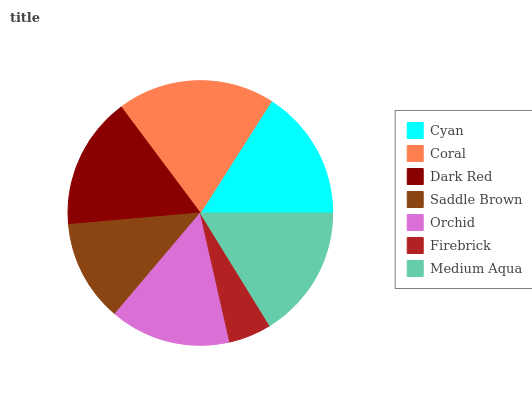Is Firebrick the minimum?
Answer yes or no. Yes. Is Coral the maximum?
Answer yes or no. Yes. Is Dark Red the minimum?
Answer yes or no. No. Is Dark Red the maximum?
Answer yes or no. No. Is Coral greater than Dark Red?
Answer yes or no. Yes. Is Dark Red less than Coral?
Answer yes or no. Yes. Is Dark Red greater than Coral?
Answer yes or no. No. Is Coral less than Dark Red?
Answer yes or no. No. Is Cyan the high median?
Answer yes or no. Yes. Is Cyan the low median?
Answer yes or no. Yes. Is Medium Aqua the high median?
Answer yes or no. No. Is Orchid the low median?
Answer yes or no. No. 